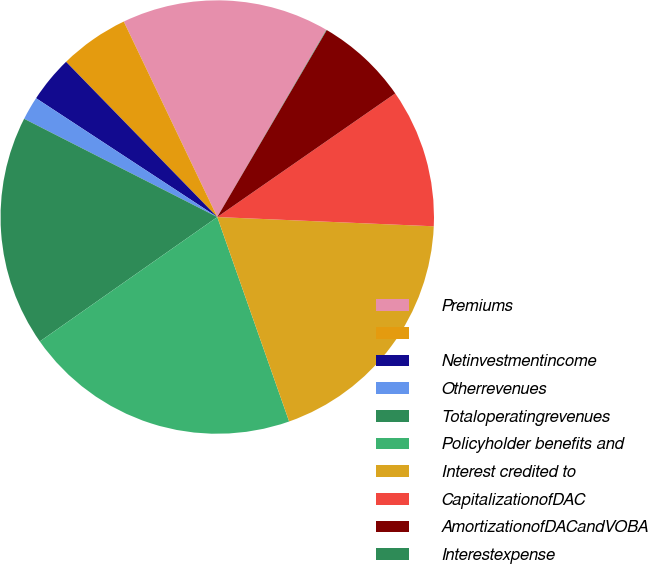<chart> <loc_0><loc_0><loc_500><loc_500><pie_chart><fcel>Premiums<fcel>Unnamed: 1<fcel>Netinvestmentincome<fcel>Otherrevenues<fcel>Totaloperatingrevenues<fcel>Policyholder benefits and<fcel>Interest credited to<fcel>CapitalizationofDAC<fcel>AmortizationofDACandVOBA<fcel>Interestexpense<nl><fcel>15.5%<fcel>5.19%<fcel>3.47%<fcel>1.75%<fcel>17.22%<fcel>20.65%<fcel>18.94%<fcel>10.34%<fcel>6.91%<fcel>0.03%<nl></chart> 